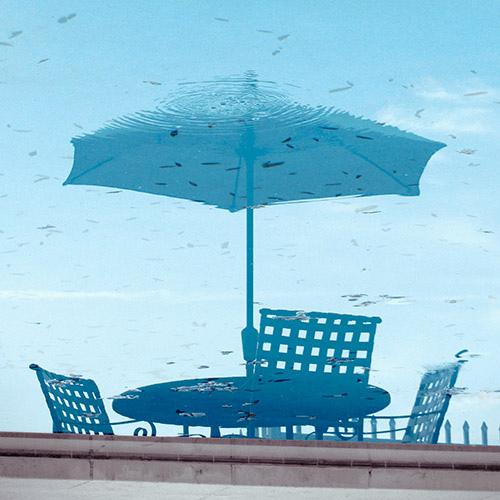Is the umbrella open?
Write a very short answer. Yes. Is this a reflection?
Write a very short answer. Yes. Is the water clean?
Concise answer only. No. 